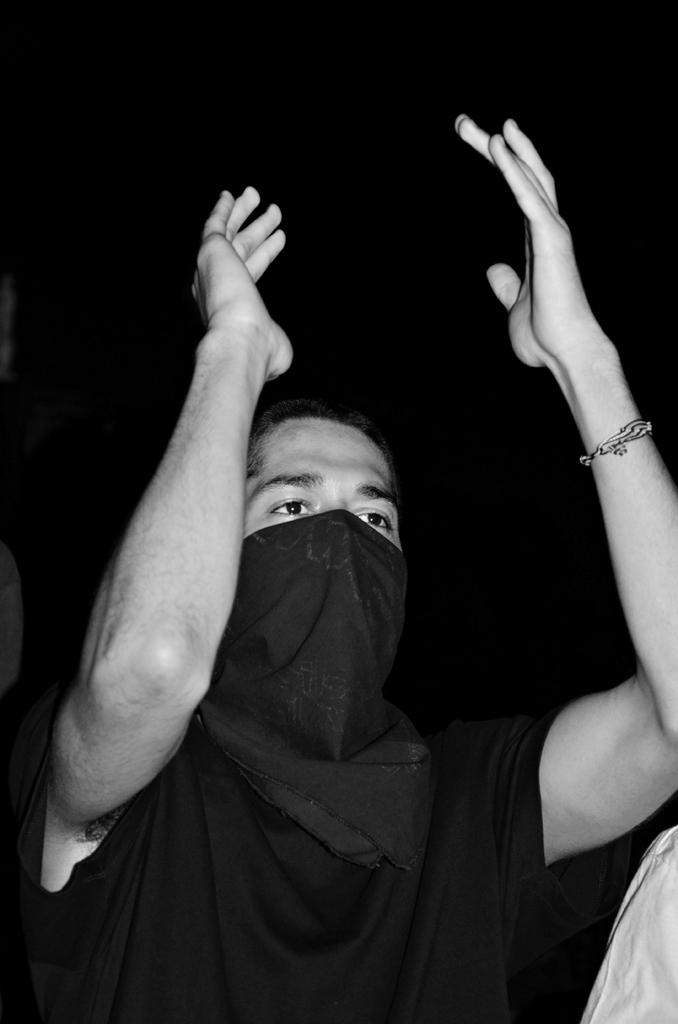What is the color scheme of the image? The image is black and white. Can you describe the person in the image? There is a person in the image, and they are covering their face with a towel. What can be seen in the background of the image? The background of the image is dark. What is the purpose of the pail in the image? There is no pail present in the image. Is the fireman in the image wearing a helmet? There is no fireman present in the image. 